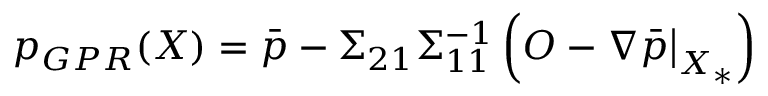Convert formula to latex. <formula><loc_0><loc_0><loc_500><loc_500>p _ { G P R } ( X ) = \bar { p } - \Sigma _ { 2 1 } \Sigma _ { 1 1 } ^ { - 1 } \left ( O - \nabla \bar { p } \Big | _ { X _ { * } } \right )</formula> 